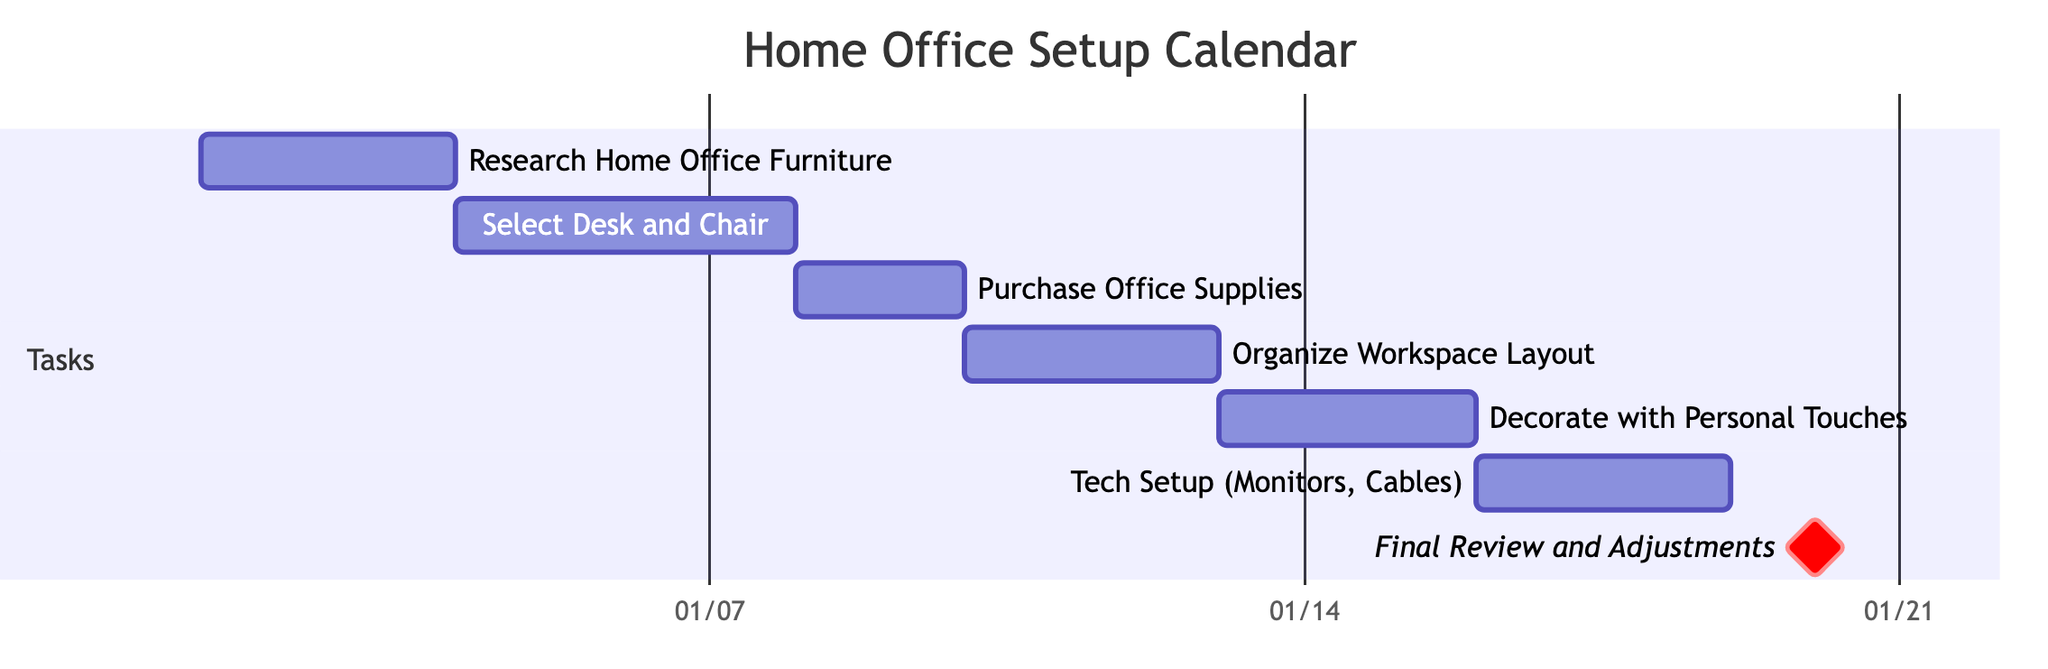What is the duration of the task "Research Home Office Furniture"? The task "Research Home Office Furniture" starts on January 1, 2024, and ends on January 3, 2024. Thus, its duration is 3 days.
Answer: 3 days How many tasks are scheduled before the "Final Review and Adjustments"? There are six tasks listed before "Final Review and Adjustments": Research Home Office Furniture, Select Desk and Chair, Purchase Office Supplies, Organize Workspace Layout, Decorate with Personal Touches, and Tech Setup (Monitors, Cables). Counting these gives a total of 6 tasks.
Answer: 6 Which task directly follows "Tech Setup (Monitors, Cables)"? "Final Review and Adjustments" is the task that comes directly after "Tech Setup (Monitors, Cables)". This can be discovered by looking at the order of tasks where "Final Review and Adjustments" is placed right after "Tech Setup (Monitors, Cables)".
Answer: Final Review and Adjustments What is the start date of the task "Purchase Office Supplies"? The task "Purchase Office Supplies" starts on January 8, 2024. This information can be derived directly from the timeline in the Gantt chart representing the dates for each task.
Answer: 2024-01-08 How long is the total duration for all tasks combined, excluding the milestone? The tasks excluding the milestone last from January 1, 2024, to January 20, 2024, giving us 20 days total. This can be calculated by counting the days between the start date of the first task (January 1) and the end of the last task before the milestone (January 20).
Answer: 20 days 